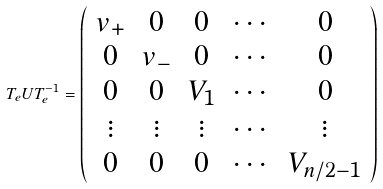<formula> <loc_0><loc_0><loc_500><loc_500>T _ { e } U T _ { e } ^ { - 1 } = \left ( \begin{array} { c c c c c } v _ { + } & 0 & 0 & \cdots & 0 \\ 0 & v _ { - } & 0 & \cdots & 0 \\ 0 & 0 & V _ { 1 } & \cdots & 0 \\ \vdots & \vdots & \vdots & \cdots & \vdots \\ 0 & 0 & 0 & \cdots & V _ { n / 2 - 1 } \\ \end{array} \right )</formula> 